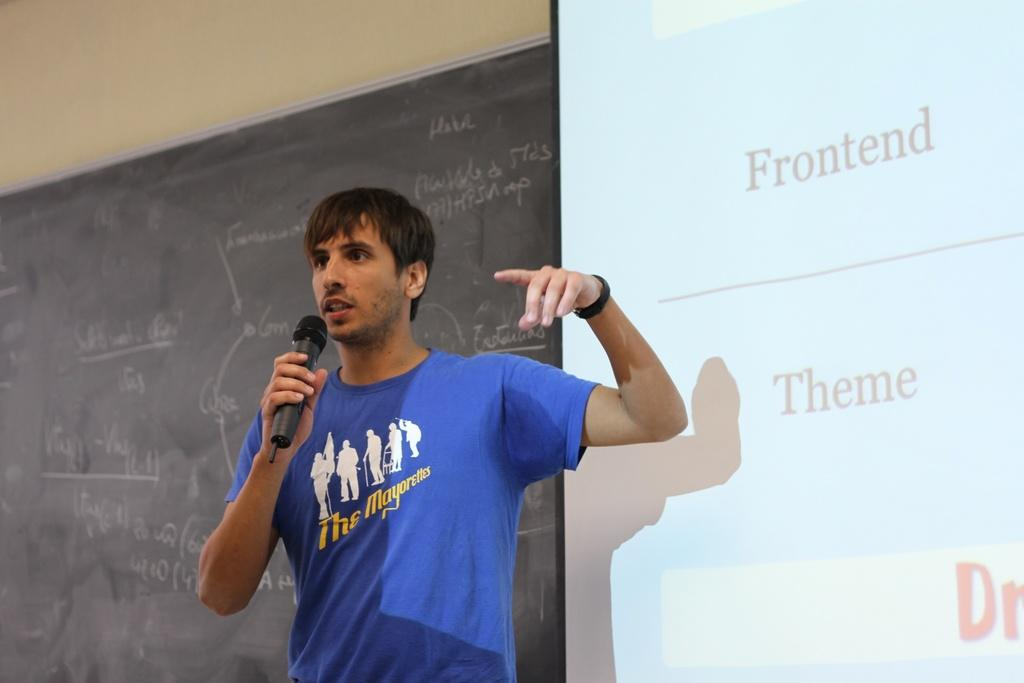What is the main subject in the foreground of the image? There is a person in the foreground of the image. What is the person holding in his hand? The person is holding a microphone in his hand. What can be seen in the background of the image? There is a board with text and a screen in the background of the image. What type of thunder can be heard in the background of the image? There is no thunder present in the image; it is a still image with no sound. 